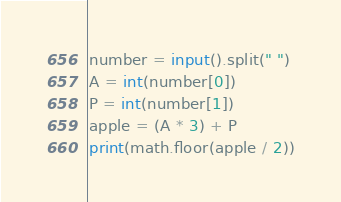<code> <loc_0><loc_0><loc_500><loc_500><_Python_>number = input().split(" ")
A = int(number[0])
P = int(number[1])
apple = (A * 3) + P
print(math.floor(apple / 2))</code> 